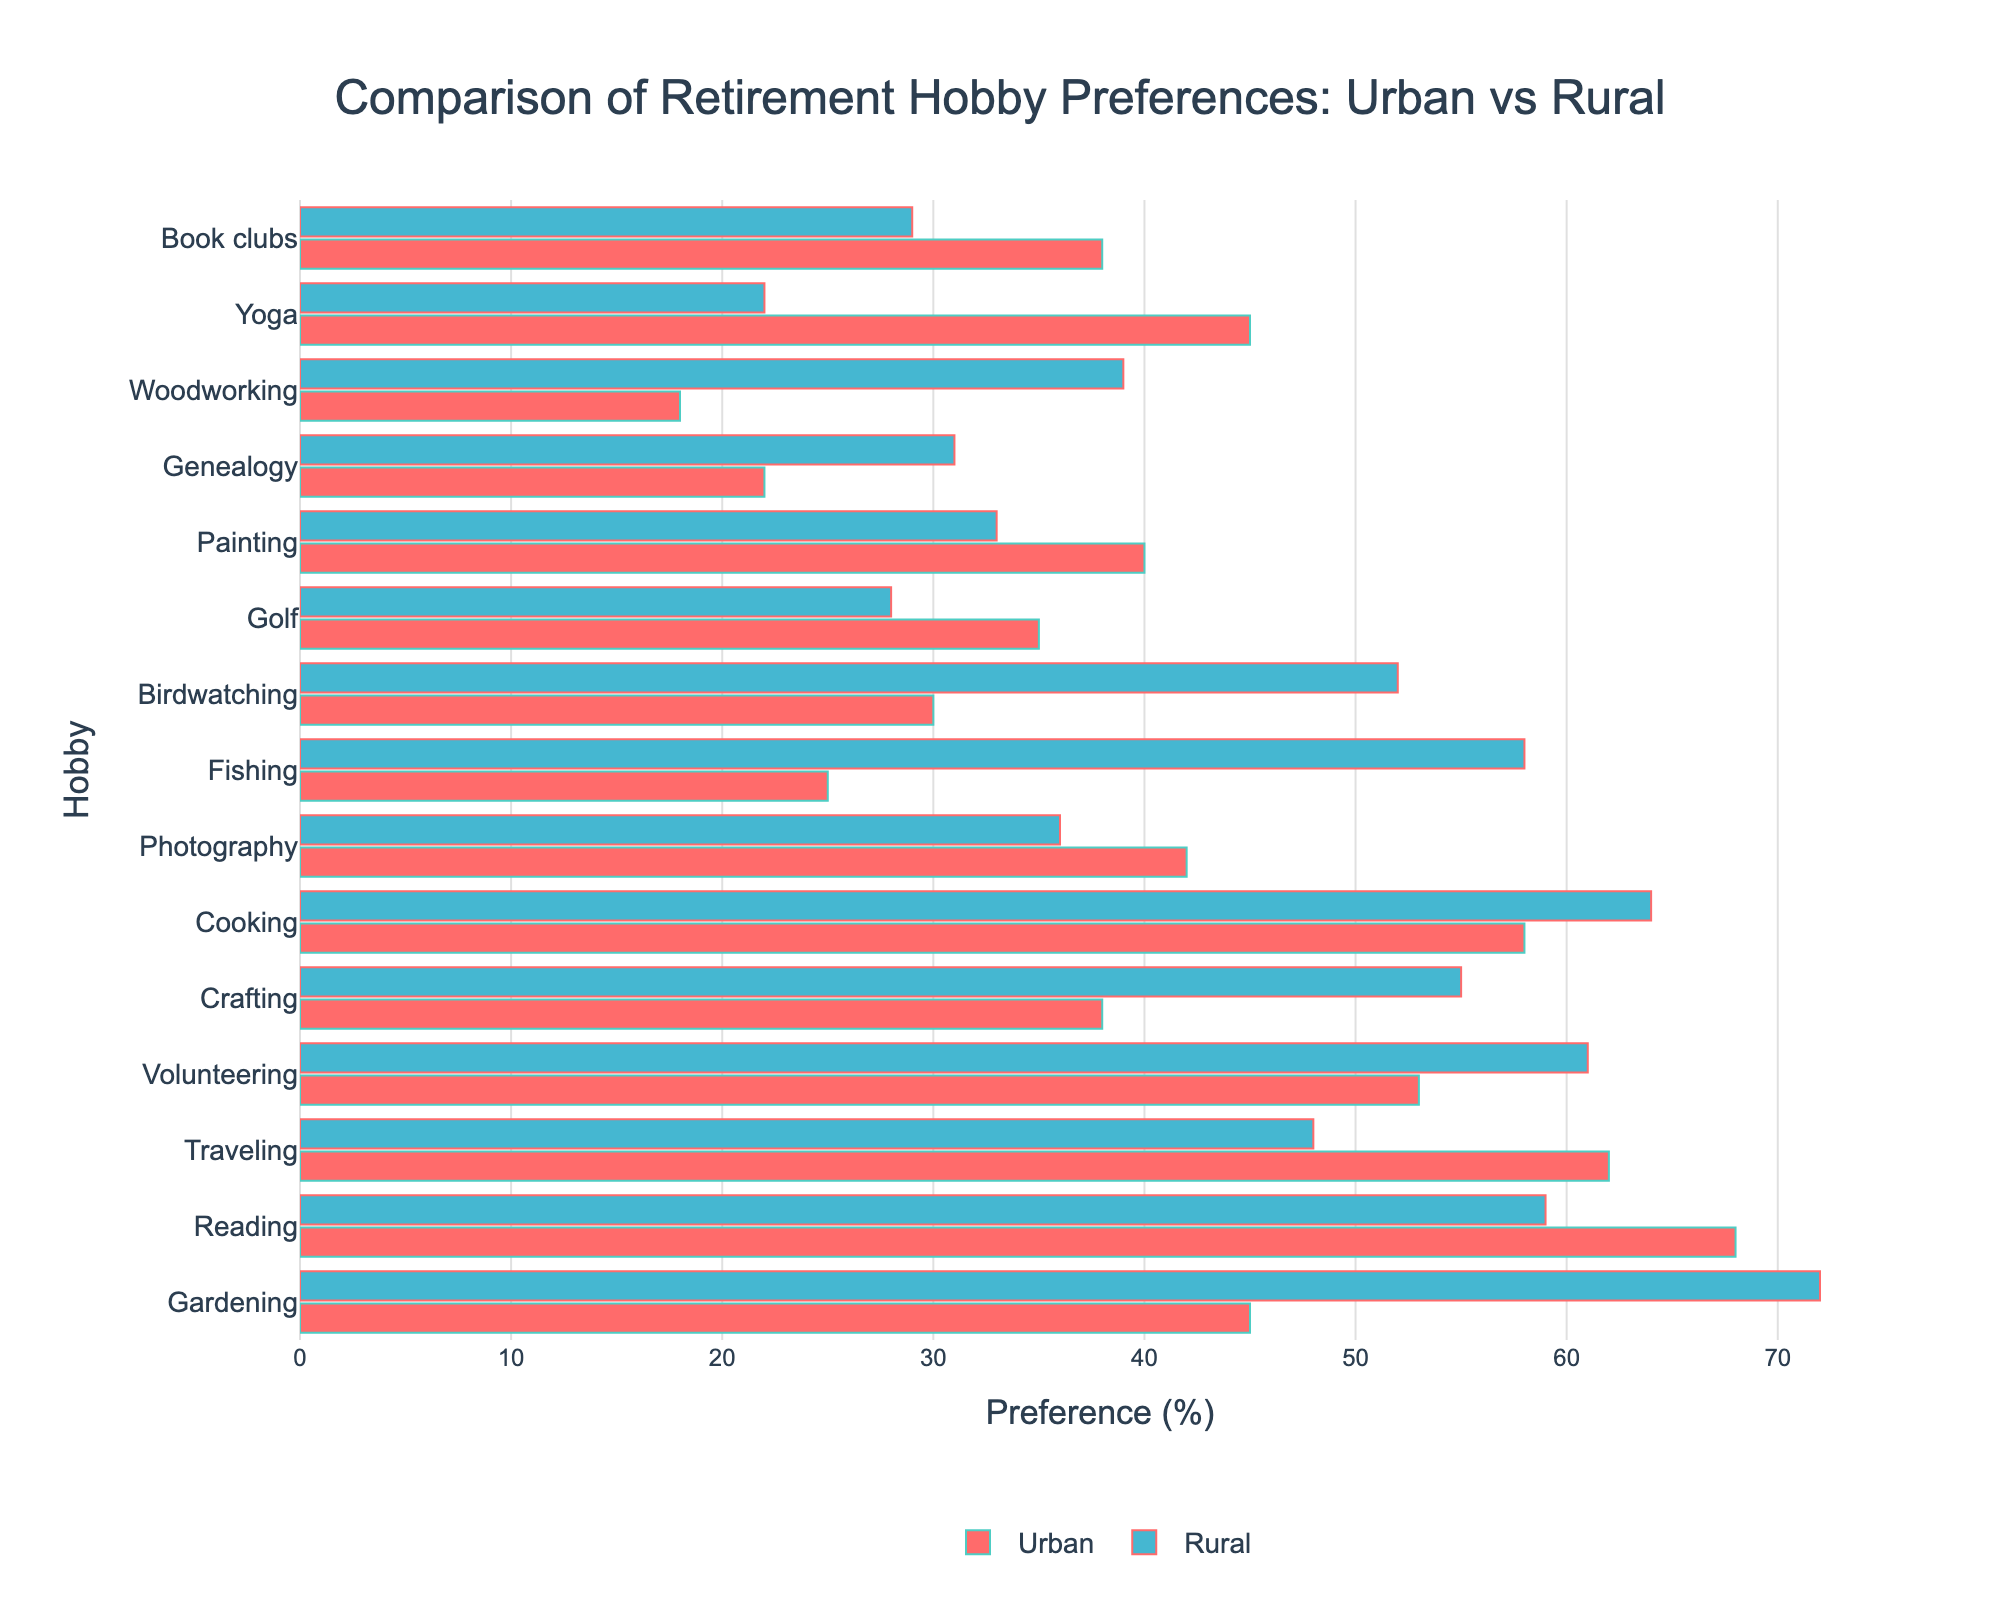Which hobby has the greatest difference in preference between rural and urban areas? To find this, we first calculate the differences in preferences for each hobby: 
- Gardening: 72 - 45 = 27
- Reading: 68 - 59 = 9
- Traveling: 62 - 48 = 14
- Volunteering: 61 - 53 = 8
- Crafting: 55 - 38 = 17
- Cooking: 64 - 58 = 6
- Photography: 42 - 36 = 6
- Fishing: 58 - 25 = 33
- Birdwatching: 52 - 30 = 22
- Golf: 35 - 28 = 7
- Painting: 40 - 33 = 7
- Genealogy: 31 - 22 = 9
- Woodworking: 39 - 18 = 21
- Yoga: 45 - 22 = 23
- Book clubs: 38 - 29 = 9
The greatest difference is in Fishing with a preference difference of 33.
Answer: Fishing Which hobby has a higher preference in urban areas compared to rural areas? To determine this, we compare preferences for each hobby:
- Gardening: Rural (72%) > Urban (45%)
- Reading: Urban (68%) > Rural (59%)
- Traveling: Urban (62%) > Rural (48%)
- Volunteering: Rural (61%) > Urban (53%)
- Crafting: Rural (55%) > Urban (38%)
- Cooking: Rural (64%) > Urban (58%)
- Photography: Urban (42%) > Rural (36%)
- Fishing: Rural (58%) > Urban (25%)
- Birdwatching: Rural (52%) > Urban (30%)
- Golf: Urban (35%) > Rural (28%)
- Painting: Urban (40%) > Rural (33%)
- Genealogy: Rural (31%) > Urban (22%)
- Woodworking: Rural (39%) > Urban (18%)
- Yoga: Urban (45%) > Rural (22%)
- Book clubs: Urban (38%) > Rural (29%)
Hobbies: Reading, Traveling, Photography, Golf, Painting, Yoga, Book clubs
Answer: Reading, Traveling, Photography, Golf, Painting, Yoga, Book clubs What is the average preference percentage for Gardening considering both urban and rural areas? The two preferences are Urban: 45% and Rural: 72%. The average is calculated by (45 + 72) / 2. 117 / 2 = 58.5%.
Answer: 58.5% Which hobby has the lowest preference in urban areas? We compare the preferences of all hobbies in urban areas:
- Gardening: 45%
- Reading: 68%
- Traveling: 62%
- Volunteering: 53%
- Crafting: 38%
- Cooking: 58%
- Photography: 42%
- Fishing: 25%
- Birdwatching: 30%
- Golf: 35%
- Painting: 40%
- Genealogy: 22%
- Woodworking: 18%
- Yoga: 45%
- Book clubs: 38%
Woodworking has the lowest preference at 18%.
Answer: Woodworking Is the preference for Cooking higher in rural areas than in urban areas? The preference percentages for Cooking are Urban: 58% and Rural: 64%. Since 64% > 58%, the preference for Cooking is higher in rural areas.
Answer: Yes Which hobbies have similar preferences in both urban and rural areas (±5%)? We look for hobbies where the difference in preferences is 5% or less:
- Gardening: 27%
- Reading: 9%
- Traveling: 14%
- Volunteering: 8%
- Crafting: 17%
- Cooking: 6%
- Photography: 6%
- Fishing: 33%
- Birdwatching: 22%
- Golf: 7%
- Painting: 7%
- Genealogy: 9%
- Woodworking: 21%
- Yoga: 23%
- Book clubs: 9%
No hobbies have a preference difference of 5% or less.
Answer: None Which hobby has the highest preference in rural areas? We compare the preferences of all hobbies in rural areas:
- Gardening: 72%
- Reading: 59%
- Traveling: 48%
- Volunteering: 61%
- Crafting: 55%
- Cooking: 64%
- Photography: 36%
- Fishing: 58%
- Birdwatching: 52%
- Golf: 28%
- Painting: 33%
- Genealogy: 31%
- Woodworking: 39%
- Yoga: 22%
- Book clubs: 29%
Gardening has the highest preference at 72%.
Answer: Gardening 